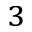<formula> <loc_0><loc_0><loc_500><loc_500>_ { 3 }</formula> 